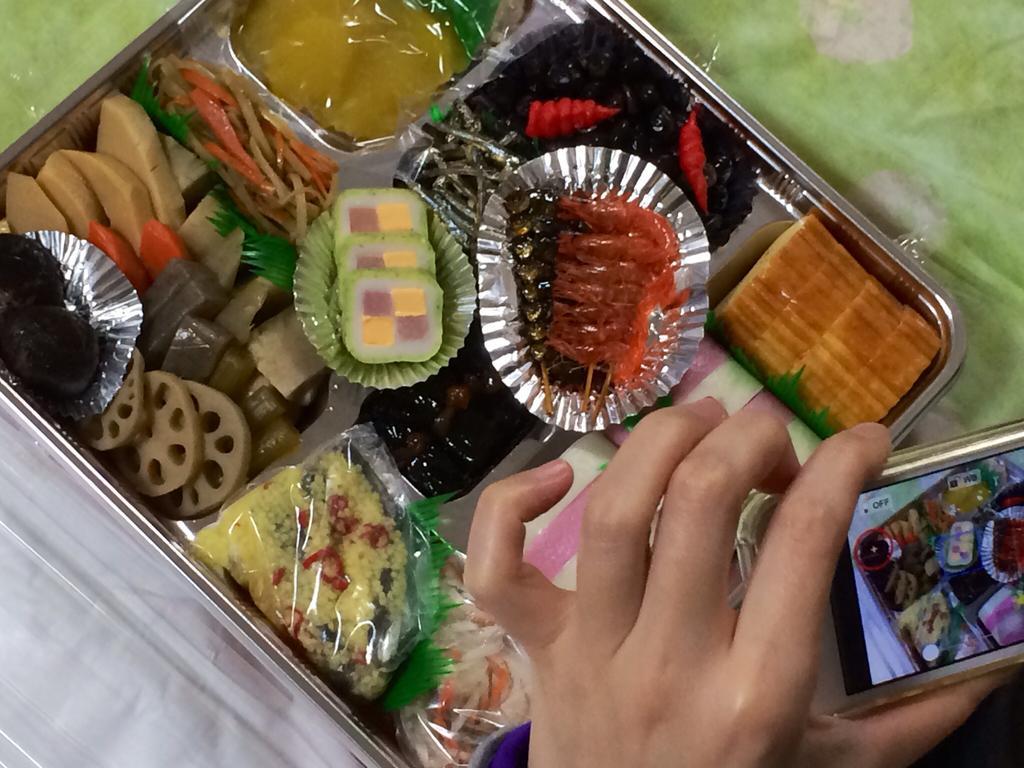Please provide a concise description of this image. In the center of the image we can see sweets in a box. We can see a person's hand and a camera. 